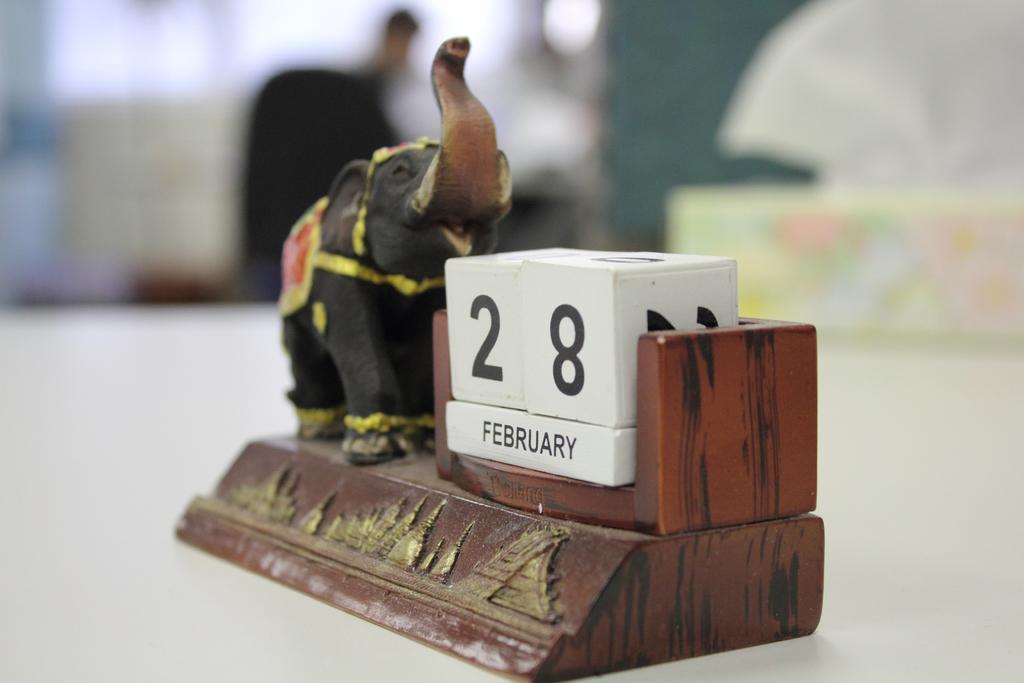In one or two sentences, can you explain what this image depicts? In the picture I can see an elephant toy and some other objects on a white color surface. The background of the image is blurred. 